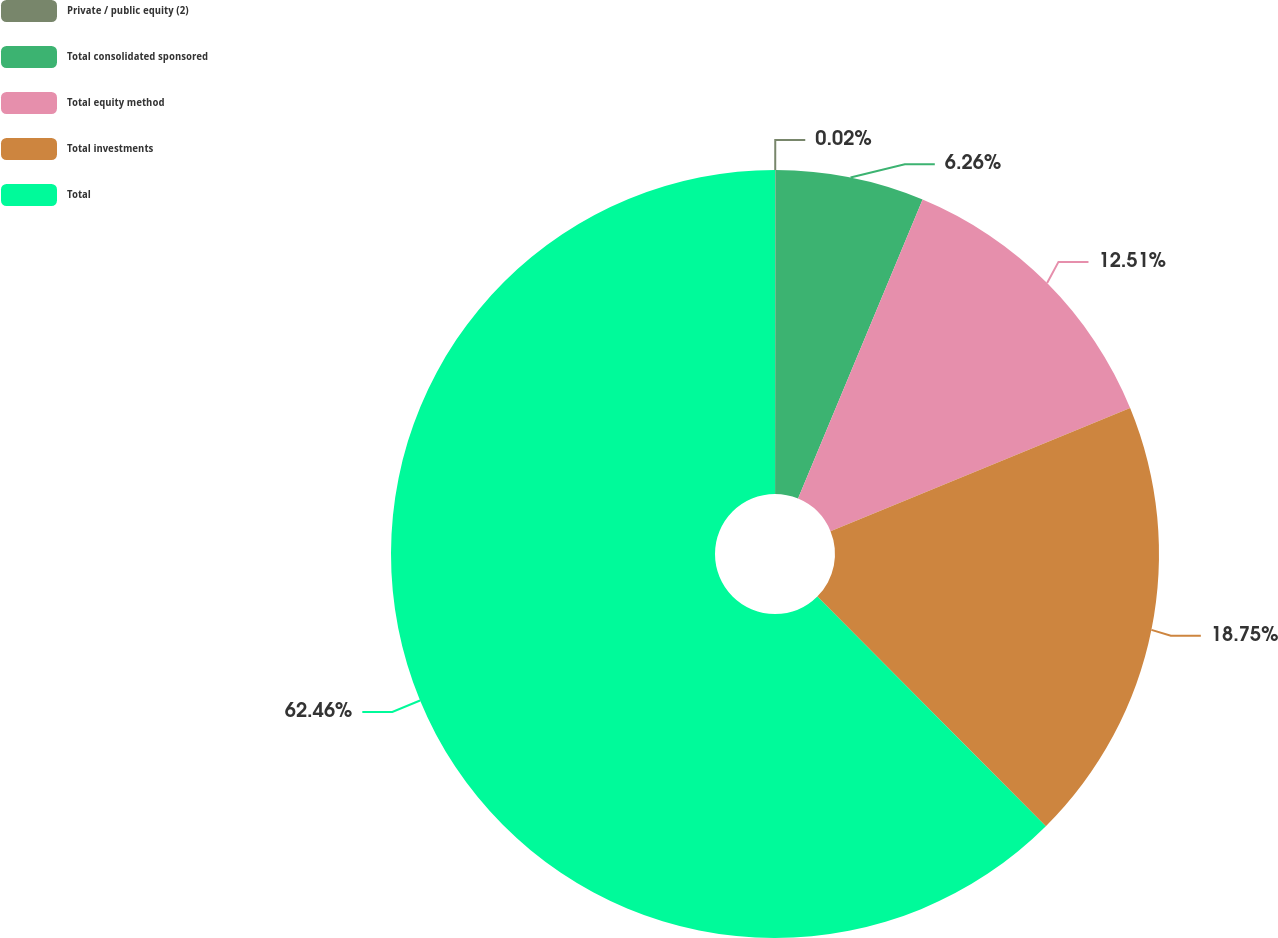<chart> <loc_0><loc_0><loc_500><loc_500><pie_chart><fcel>Private / public equity (2)<fcel>Total consolidated sponsored<fcel>Total equity method<fcel>Total investments<fcel>Total<nl><fcel>0.02%<fcel>6.26%<fcel>12.51%<fcel>18.75%<fcel>62.46%<nl></chart> 